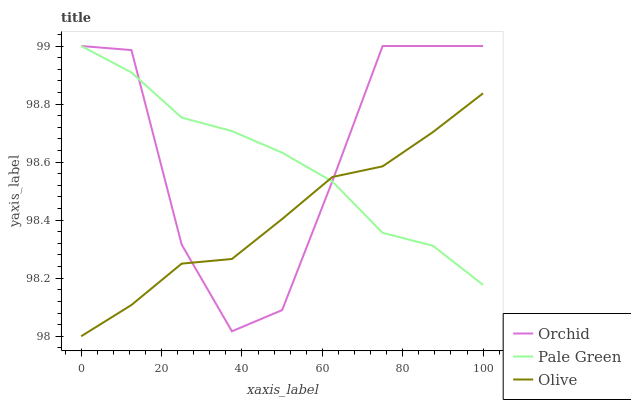Does Olive have the minimum area under the curve?
Answer yes or no. Yes. Does Orchid have the maximum area under the curve?
Answer yes or no. Yes. Does Pale Green have the minimum area under the curve?
Answer yes or no. No. Does Pale Green have the maximum area under the curve?
Answer yes or no. No. Is Olive the smoothest?
Answer yes or no. Yes. Is Orchid the roughest?
Answer yes or no. Yes. Is Pale Green the smoothest?
Answer yes or no. No. Is Pale Green the roughest?
Answer yes or no. No. Does Olive have the lowest value?
Answer yes or no. Yes. Does Orchid have the lowest value?
Answer yes or no. No. Does Orchid have the highest value?
Answer yes or no. Yes. Does Pale Green intersect Orchid?
Answer yes or no. Yes. Is Pale Green less than Orchid?
Answer yes or no. No. Is Pale Green greater than Orchid?
Answer yes or no. No. 